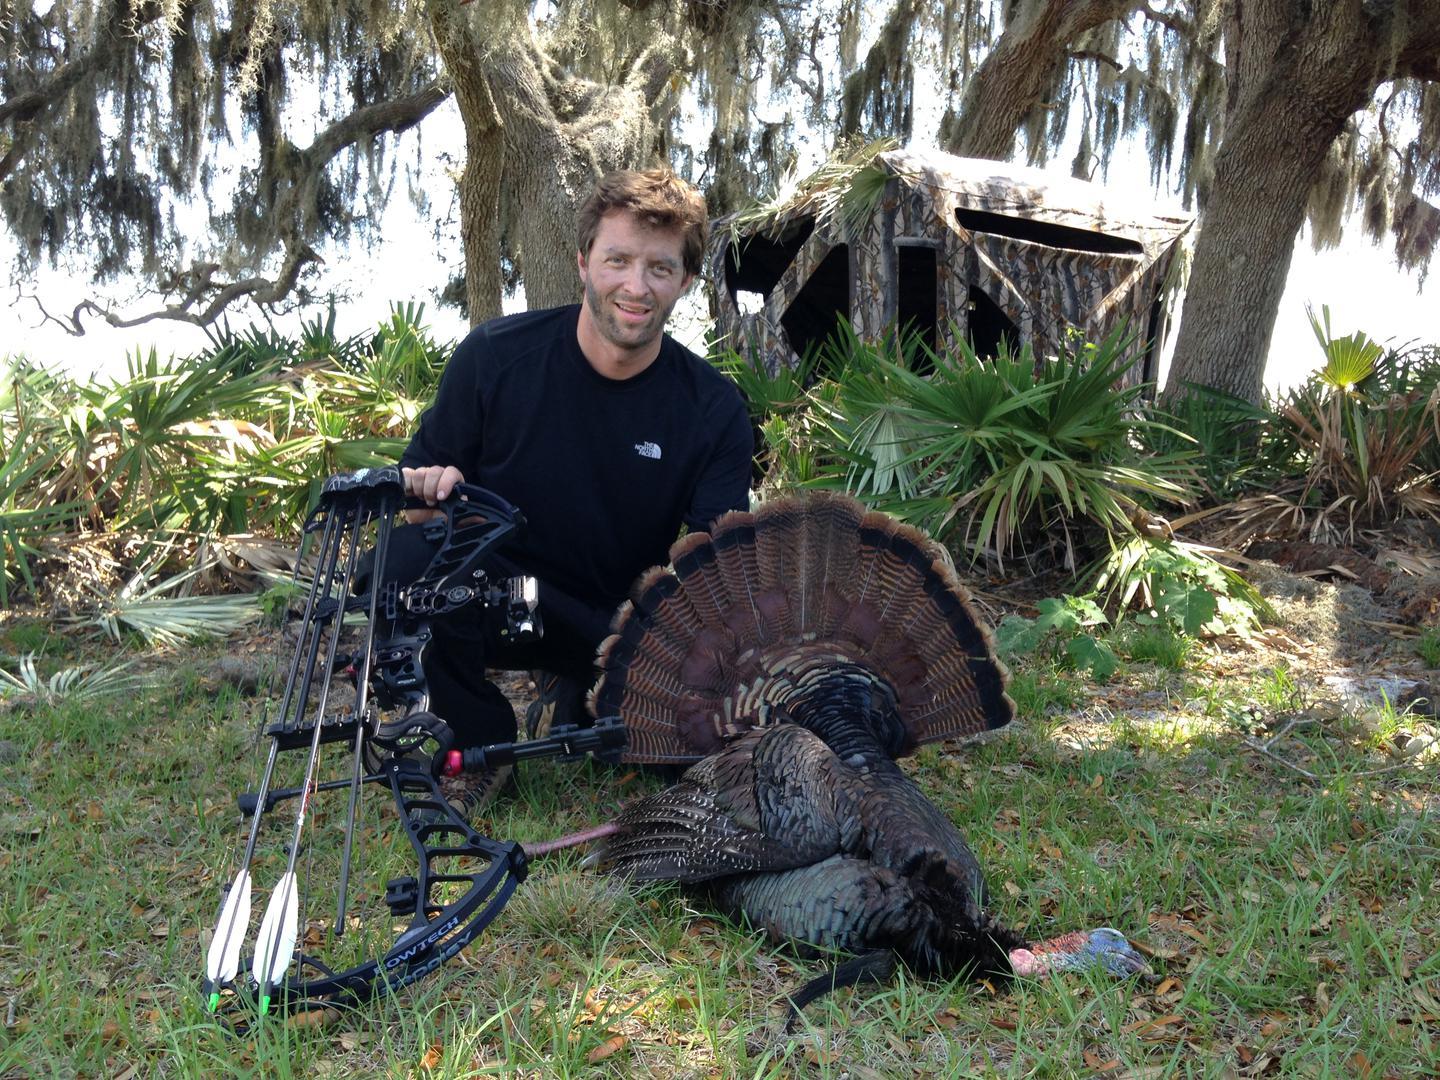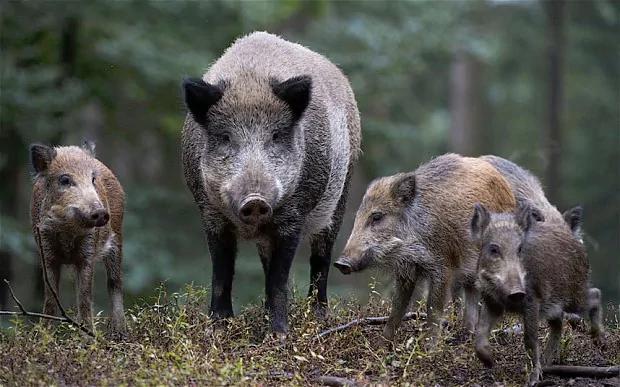The first image is the image on the left, the second image is the image on the right. Examine the images to the left and right. Is the description "In total, two dead hogs are shown." accurate? Answer yes or no. No. The first image is the image on the left, the second image is the image on the right. Examine the images to the left and right. Is the description "Two hunters are posing with their kill in the image on the right." accurate? Answer yes or no. No. 